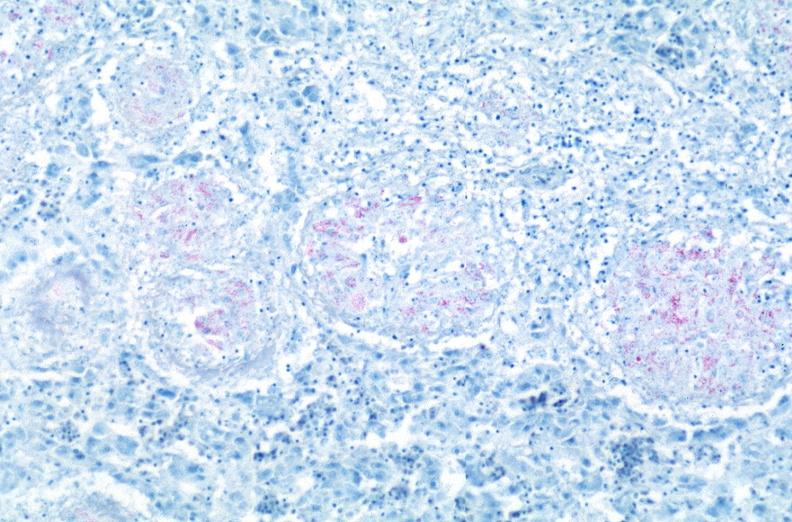does this image show lung, mycobacterium tuberculosis, acid fast?
Answer the question using a single word or phrase. Yes 